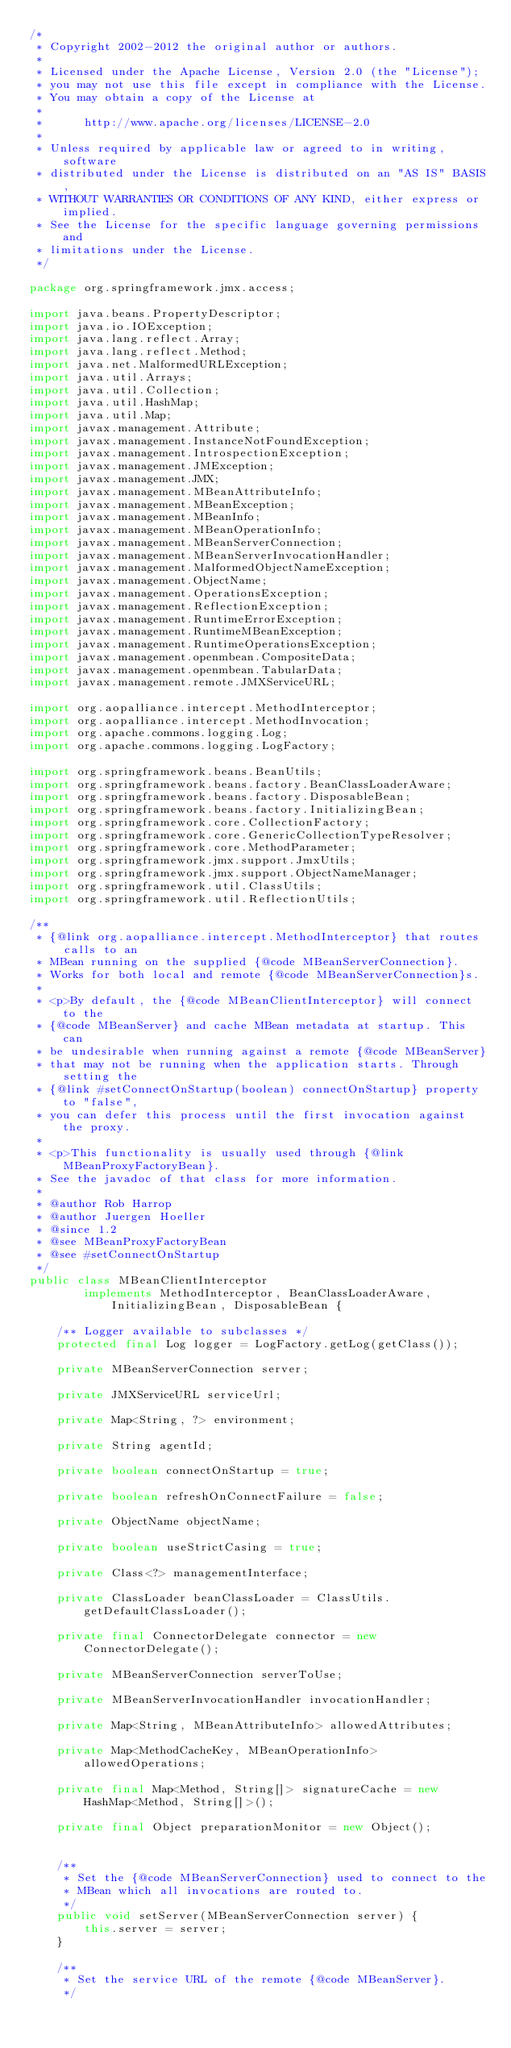Convert code to text. <code><loc_0><loc_0><loc_500><loc_500><_Java_>/*
 * Copyright 2002-2012 the original author or authors.
 *
 * Licensed under the Apache License, Version 2.0 (the "License");
 * you may not use this file except in compliance with the License.
 * You may obtain a copy of the License at
 *
 *      http://www.apache.org/licenses/LICENSE-2.0
 *
 * Unless required by applicable law or agreed to in writing, software
 * distributed under the License is distributed on an "AS IS" BASIS,
 * WITHOUT WARRANTIES OR CONDITIONS OF ANY KIND, either express or implied.
 * See the License for the specific language governing permissions and
 * limitations under the License.
 */

package org.springframework.jmx.access;

import java.beans.PropertyDescriptor;
import java.io.IOException;
import java.lang.reflect.Array;
import java.lang.reflect.Method;
import java.net.MalformedURLException;
import java.util.Arrays;
import java.util.Collection;
import java.util.HashMap;
import java.util.Map;
import javax.management.Attribute;
import javax.management.InstanceNotFoundException;
import javax.management.IntrospectionException;
import javax.management.JMException;
import javax.management.JMX;
import javax.management.MBeanAttributeInfo;
import javax.management.MBeanException;
import javax.management.MBeanInfo;
import javax.management.MBeanOperationInfo;
import javax.management.MBeanServerConnection;
import javax.management.MBeanServerInvocationHandler;
import javax.management.MalformedObjectNameException;
import javax.management.ObjectName;
import javax.management.OperationsException;
import javax.management.ReflectionException;
import javax.management.RuntimeErrorException;
import javax.management.RuntimeMBeanException;
import javax.management.RuntimeOperationsException;
import javax.management.openmbean.CompositeData;
import javax.management.openmbean.TabularData;
import javax.management.remote.JMXServiceURL;

import org.aopalliance.intercept.MethodInterceptor;
import org.aopalliance.intercept.MethodInvocation;
import org.apache.commons.logging.Log;
import org.apache.commons.logging.LogFactory;

import org.springframework.beans.BeanUtils;
import org.springframework.beans.factory.BeanClassLoaderAware;
import org.springframework.beans.factory.DisposableBean;
import org.springframework.beans.factory.InitializingBean;
import org.springframework.core.CollectionFactory;
import org.springframework.core.GenericCollectionTypeResolver;
import org.springframework.core.MethodParameter;
import org.springframework.jmx.support.JmxUtils;
import org.springframework.jmx.support.ObjectNameManager;
import org.springframework.util.ClassUtils;
import org.springframework.util.ReflectionUtils;

/**
 * {@link org.aopalliance.intercept.MethodInterceptor} that routes calls to an
 * MBean running on the supplied {@code MBeanServerConnection}.
 * Works for both local and remote {@code MBeanServerConnection}s.
 *
 * <p>By default, the {@code MBeanClientInterceptor} will connect to the
 * {@code MBeanServer} and cache MBean metadata at startup. This can
 * be undesirable when running against a remote {@code MBeanServer}
 * that may not be running when the application starts. Through setting the
 * {@link #setConnectOnStartup(boolean) connectOnStartup} property to "false",
 * you can defer this process until the first invocation against the proxy.
 *
 * <p>This functionality is usually used through {@link MBeanProxyFactoryBean}.
 * See the javadoc of that class for more information.
 *
 * @author Rob Harrop
 * @author Juergen Hoeller
 * @since 1.2
 * @see MBeanProxyFactoryBean
 * @see #setConnectOnStartup
 */
public class MBeanClientInterceptor
		implements MethodInterceptor, BeanClassLoaderAware, InitializingBean, DisposableBean {

	/** Logger available to subclasses */
	protected final Log logger = LogFactory.getLog(getClass());

	private MBeanServerConnection server;

	private JMXServiceURL serviceUrl;

	private Map<String, ?> environment;

	private String agentId;

	private boolean connectOnStartup = true;

	private boolean refreshOnConnectFailure = false;

	private ObjectName objectName;

	private boolean useStrictCasing = true;

	private Class<?> managementInterface;

	private ClassLoader beanClassLoader = ClassUtils.getDefaultClassLoader();

	private final ConnectorDelegate connector = new ConnectorDelegate();

	private MBeanServerConnection serverToUse;

	private MBeanServerInvocationHandler invocationHandler;

	private Map<String, MBeanAttributeInfo> allowedAttributes;

	private Map<MethodCacheKey, MBeanOperationInfo> allowedOperations;

	private final Map<Method, String[]> signatureCache = new HashMap<Method, String[]>();

	private final Object preparationMonitor = new Object();


	/**
	 * Set the {@code MBeanServerConnection} used to connect to the
	 * MBean which all invocations are routed to.
	 */
	public void setServer(MBeanServerConnection server) {
		this.server = server;
	}

	/**
	 * Set the service URL of the remote {@code MBeanServer}.
	 */</code> 